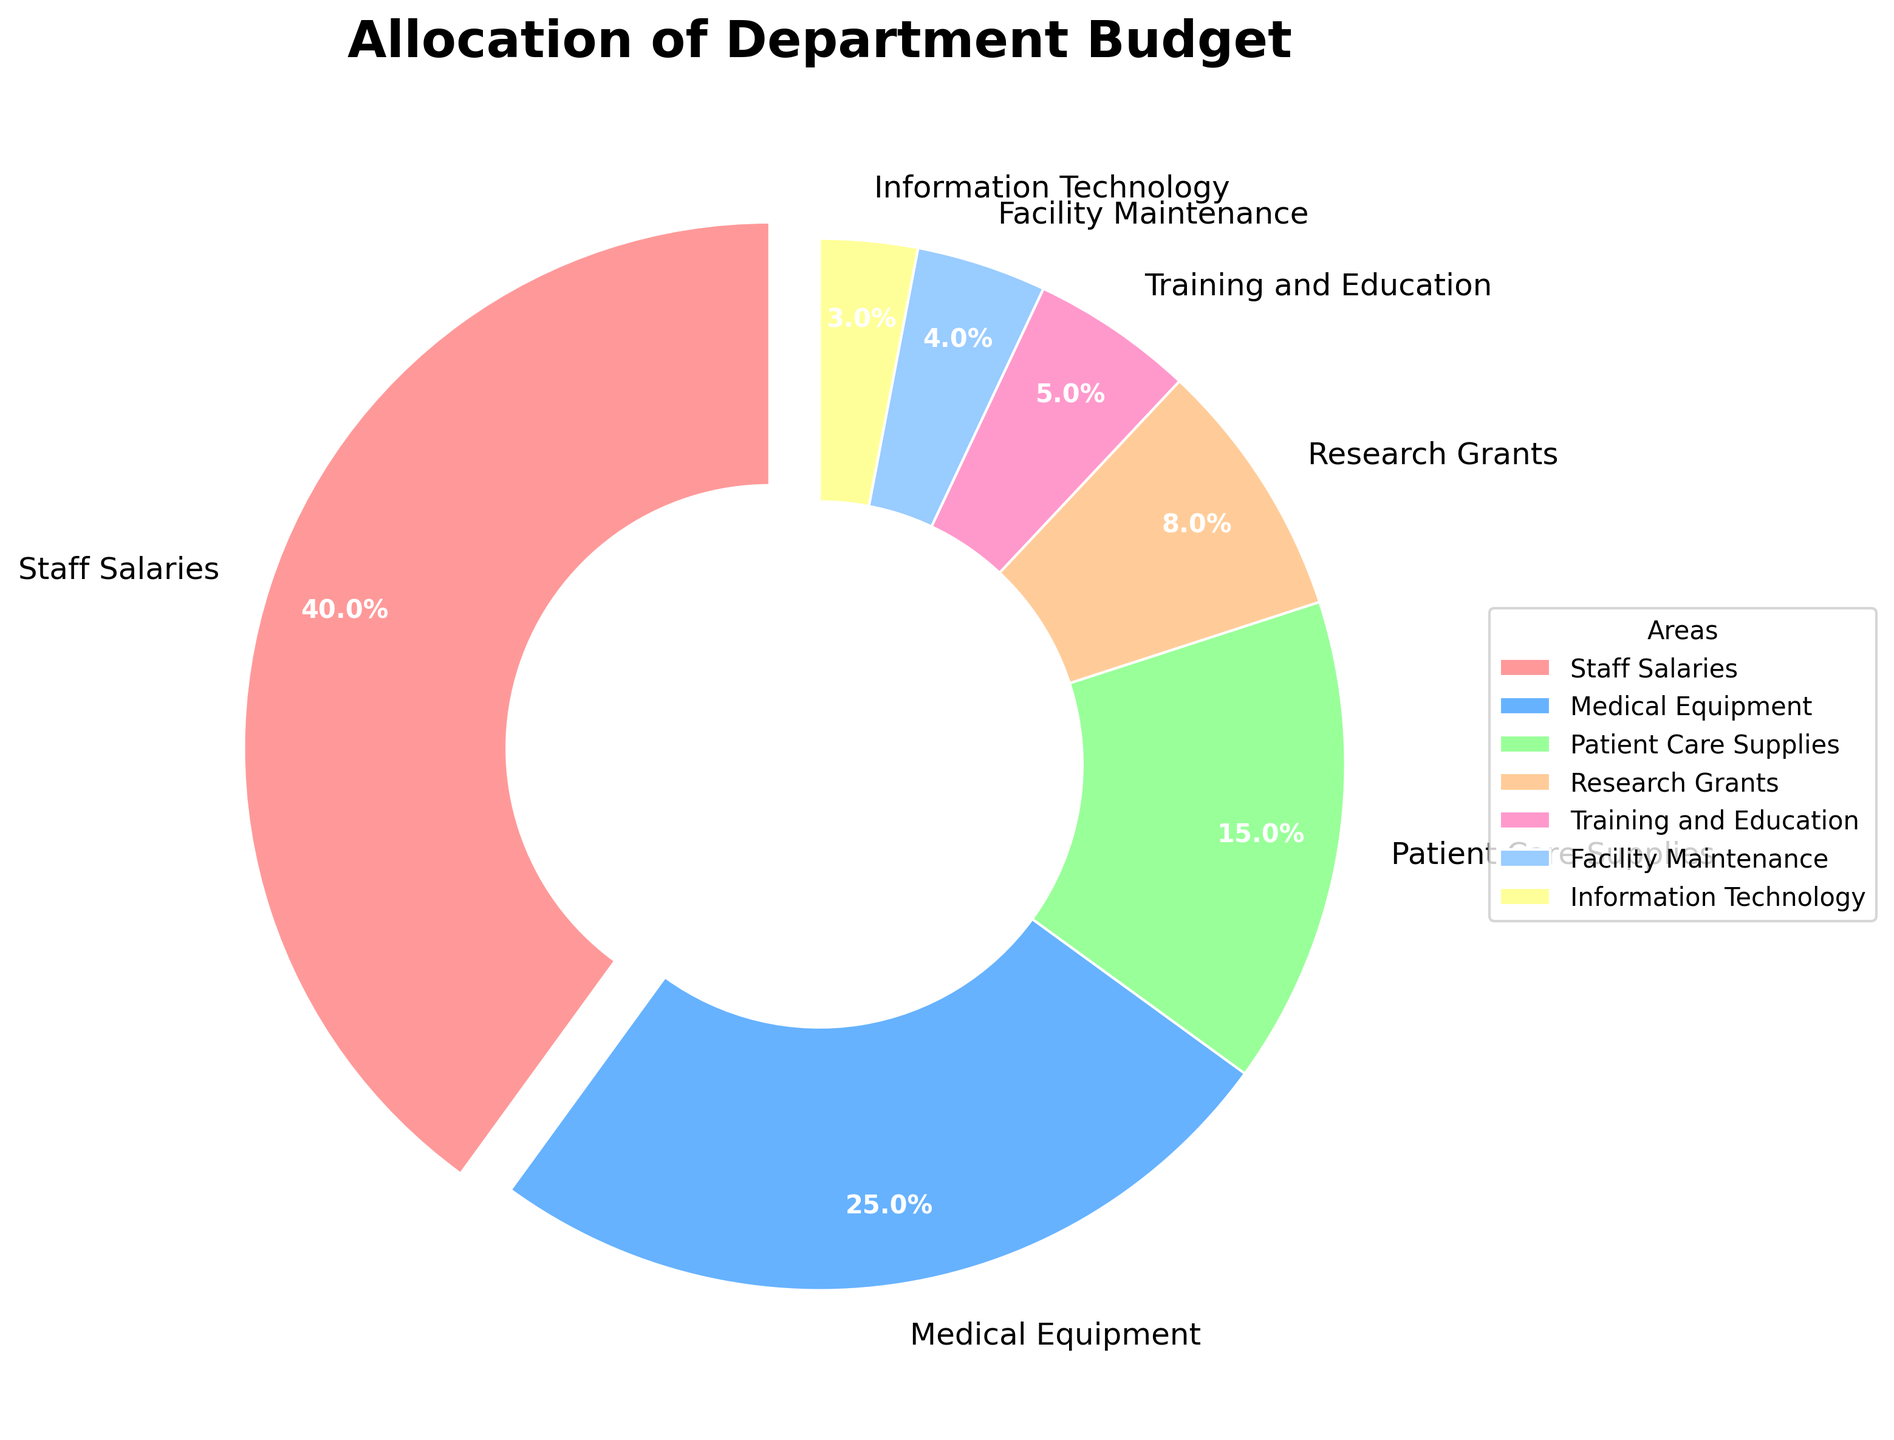what percentage of the budget is allocated to staff salaries? Staff Salaries have a segment in the pie chart labeled with 40%. This corresponds to the percentage of the budget allocated to it.
Answer: 40% which area receives the least amount of the budget? By observing the pie chart, we can see that Information Technology has the smallest segment labeled 3%.
Answer: Information Technology how much more budget is allocated to medical equipment compared to training and education? Medical Equipment is allocated 25%, and Training and Education is allocated 5%. The difference is calculated as 25% - 5% = 20%.
Answer: 20% what is the combined budget allocation for medical equipment and research grants? Medical Equipment is allocated 25% and Research Grants are allocated 8%. The combined allocation is 25% + 8% = 33%.
Answer: 33% which areas combined make up 50% of the budget? We see from the pie chart that Staff Salaries (40%) and Patient Care Supplies (15%) together make up more than 50%. But if we combine Staff Salaries (40%) and Medical Equipment (25%), they sum to 65%. To exactly get 50%, we have to consider Staff Salaries (40%) and adding next highest Patient Care Supplies (15%) gives 55%. Thus, none can exactly sum up to 50%, larger closest coming up is Staff and Equipment with 65%.
Answer: None exactly 50% is the budget allocated to facility maintenance greater than that to information technology? Facility Maintenance is allocated 4% and Information Technology is allocated 3%. Since 4% is greater than 3%, Facility Maintenance has a higher budget allocation.
Answer: Yes what proportion of the budget is allocated to patient care supplies compared to medical equipment? Patient Care Supplies have a 15% budget allocation, and Medical Equipment has a 25% allocation. The ratio of Patient Care Supplies to Medical Equipment is 15/25 = 0.6 (or 60%).
Answer: 60% what are the second highest and second lowest budget allocations, and what are their percentages? The second highest allocation is Medical Equipment at 25%, and the second lowest allocation is Facility Maintenance at 4%.
Answer: Medical Equipment (25%), Facility Maintenance (4%) which areas have budget allocations greater than 10%? From the pie chart, Staff Salaries (40%), Medical Equipment (25%), and Patient Care Supplies (15%) all have budget allocations greater than 10%.
Answer: Staff Salaries, Medical Equipment, Patient Care Supplies how much of the budget is allocated to non-staff-related areas? Staff Salaries account for 40% of the budget. To find the non-staff-related areas’ budget, subtract this from 100%: 100% - 40% = 60%.
Answer: 60% 